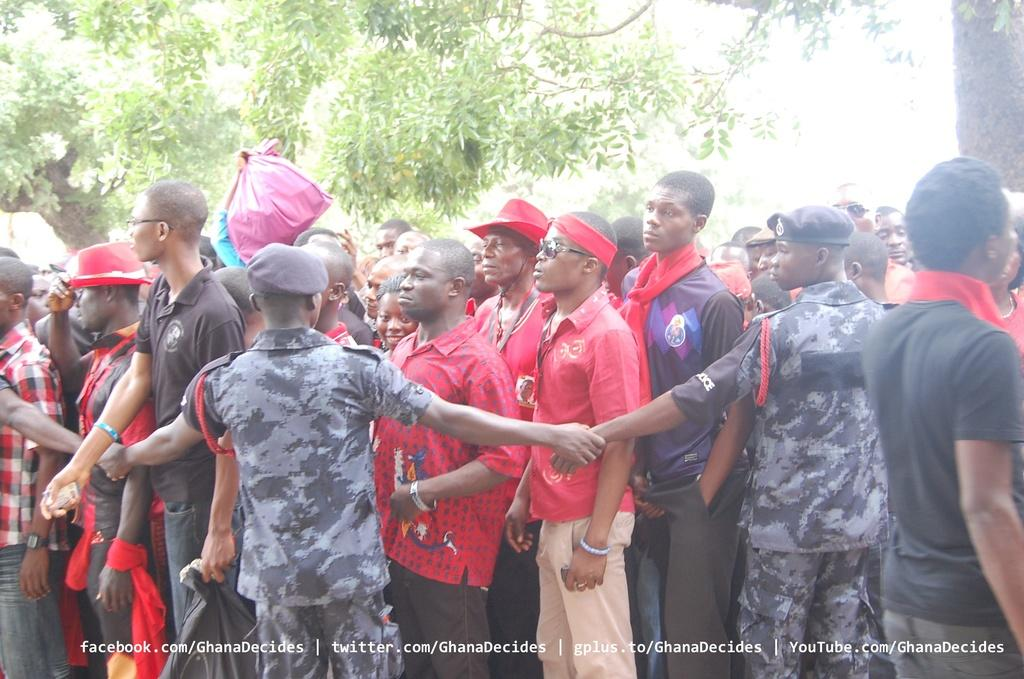What is the main subject of the image? The main subject of the image is a crowd of people. What are some people in the crowd wearing on their heads? Some people in the crowd are wearing caps and hats. What can be seen in the background of the image? There are trees visible in the background of the image. What is written at the bottom of the image? There is text written at the bottom of the image. What is a person holding in the image? There is a person holding a packet in the image. What type of advice is being given to the crowd in the image? There is no indication in the image that any advice is being given to the crowd. What disease is affecting the people in the crowd in the image? There is no indication in the image that any disease is affecting the people in the crowd. 